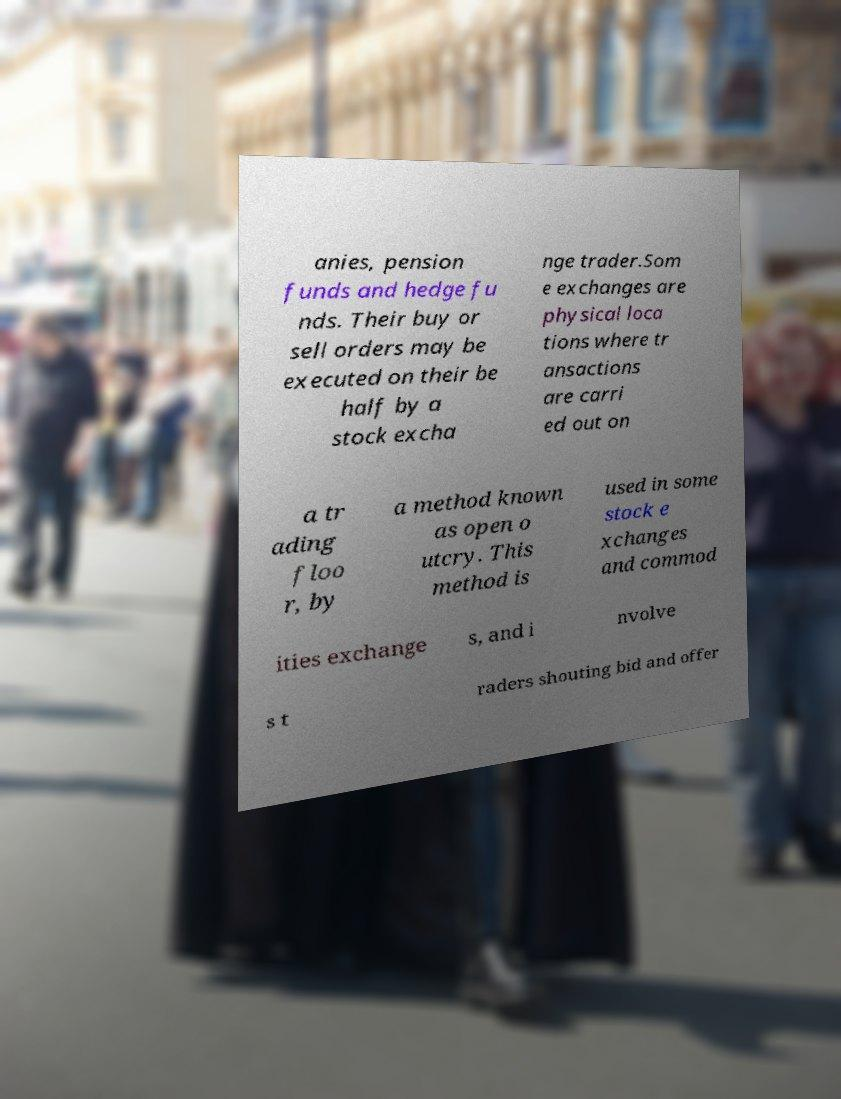Could you extract and type out the text from this image? anies, pension funds and hedge fu nds. Their buy or sell orders may be executed on their be half by a stock excha nge trader.Som e exchanges are physical loca tions where tr ansactions are carri ed out on a tr ading floo r, by a method known as open o utcry. This method is used in some stock e xchanges and commod ities exchange s, and i nvolve s t raders shouting bid and offer 